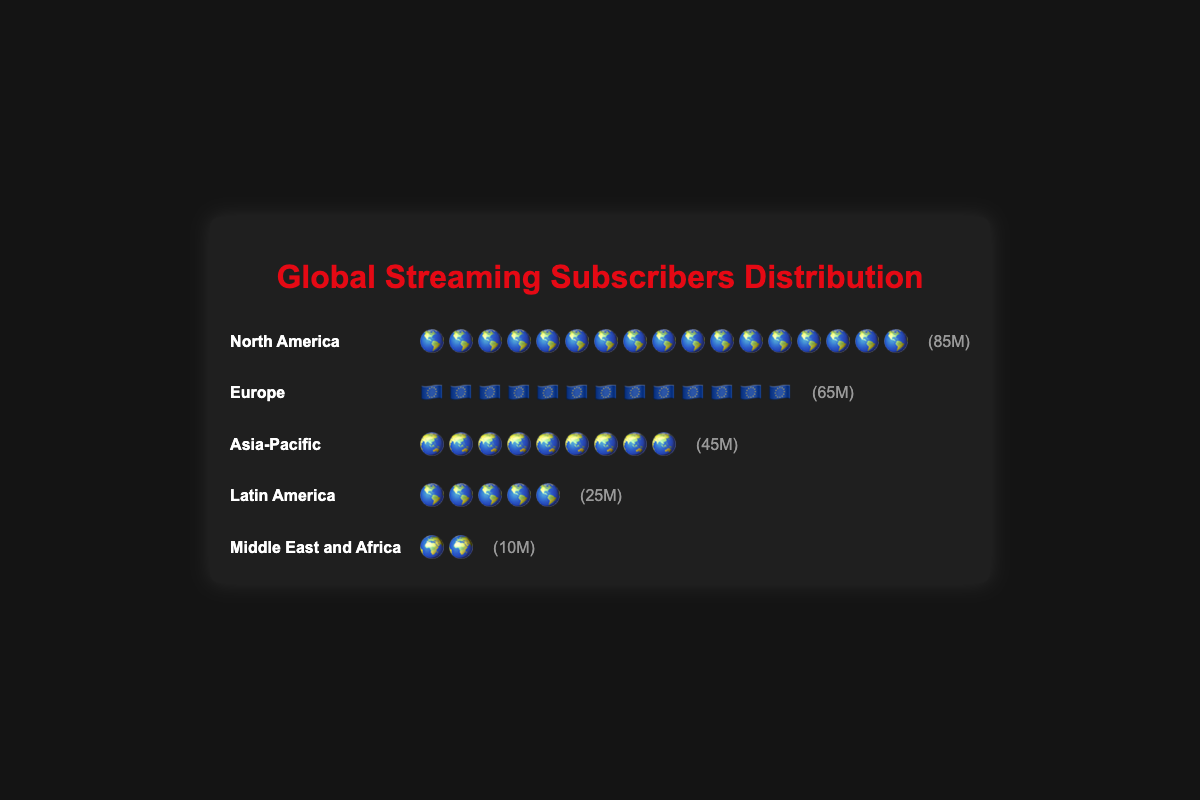How many subscriber units represent North America? Each icon represents 5 million subscribers. North America has 17 icons, so 17 x 5 million = 85 million.
Answer: 85 million Which region has the least subscribers and how many units does it have? Middle East and Africa has the least subscribers with 2 icons representing 2 x 5 million = 10 million subscribers.
Answer: Middle East and Africa, 10 million Which region has more subscribers: Latin America or Europe? Latin America has 5 icons and Europe has 13 icons. Therefore, Europe has more subscribers.
Answer: Europe How many subscribers do Europe and Asia-Pacific have in total? Europe has 13 icons (13 x 5 million) and Asia-Pacific has 9 icons (9 x 5 million). Their total is (13 + 9) x 5 million = 110 million.
Answer: 110 million What percentage of the total subscribers does North America have? The total subscribers across all regions are 85 + 65 + 45 + 25 + 10 = 230 million. North America's share is (85 / 230) x 100 ≈ 36.96%.
Answer: 36.96% How many more subscribers does North America have compared to the Asia-Pacific? North America has 85 million subscribers and Asia-Pacific has 45 million. The difference is 85 - 45 = 40 million.
Answer: 40 million Rank the regions from most to least subscribers. North America (85M), Europe (65M), Asia-Pacific (45M), Latin America (25M), Middle East and Africa (10M).
Answer: North America, Europe, Asia-Pacific, Latin America, Middle East and Africa Which regions share the same visual icon? North America and Latin America both use the globe (🌎) icon.
Answer: North America and Latin America If each icon represents 5 million subscribers, how many icons are displayed altogether? Sum of all icons: North America (17) + Europe (13) + Asia-Pacific (9) + Latin America (5) + Middle East and Africa (2) = 46 icons.
Answer: 46 icons 